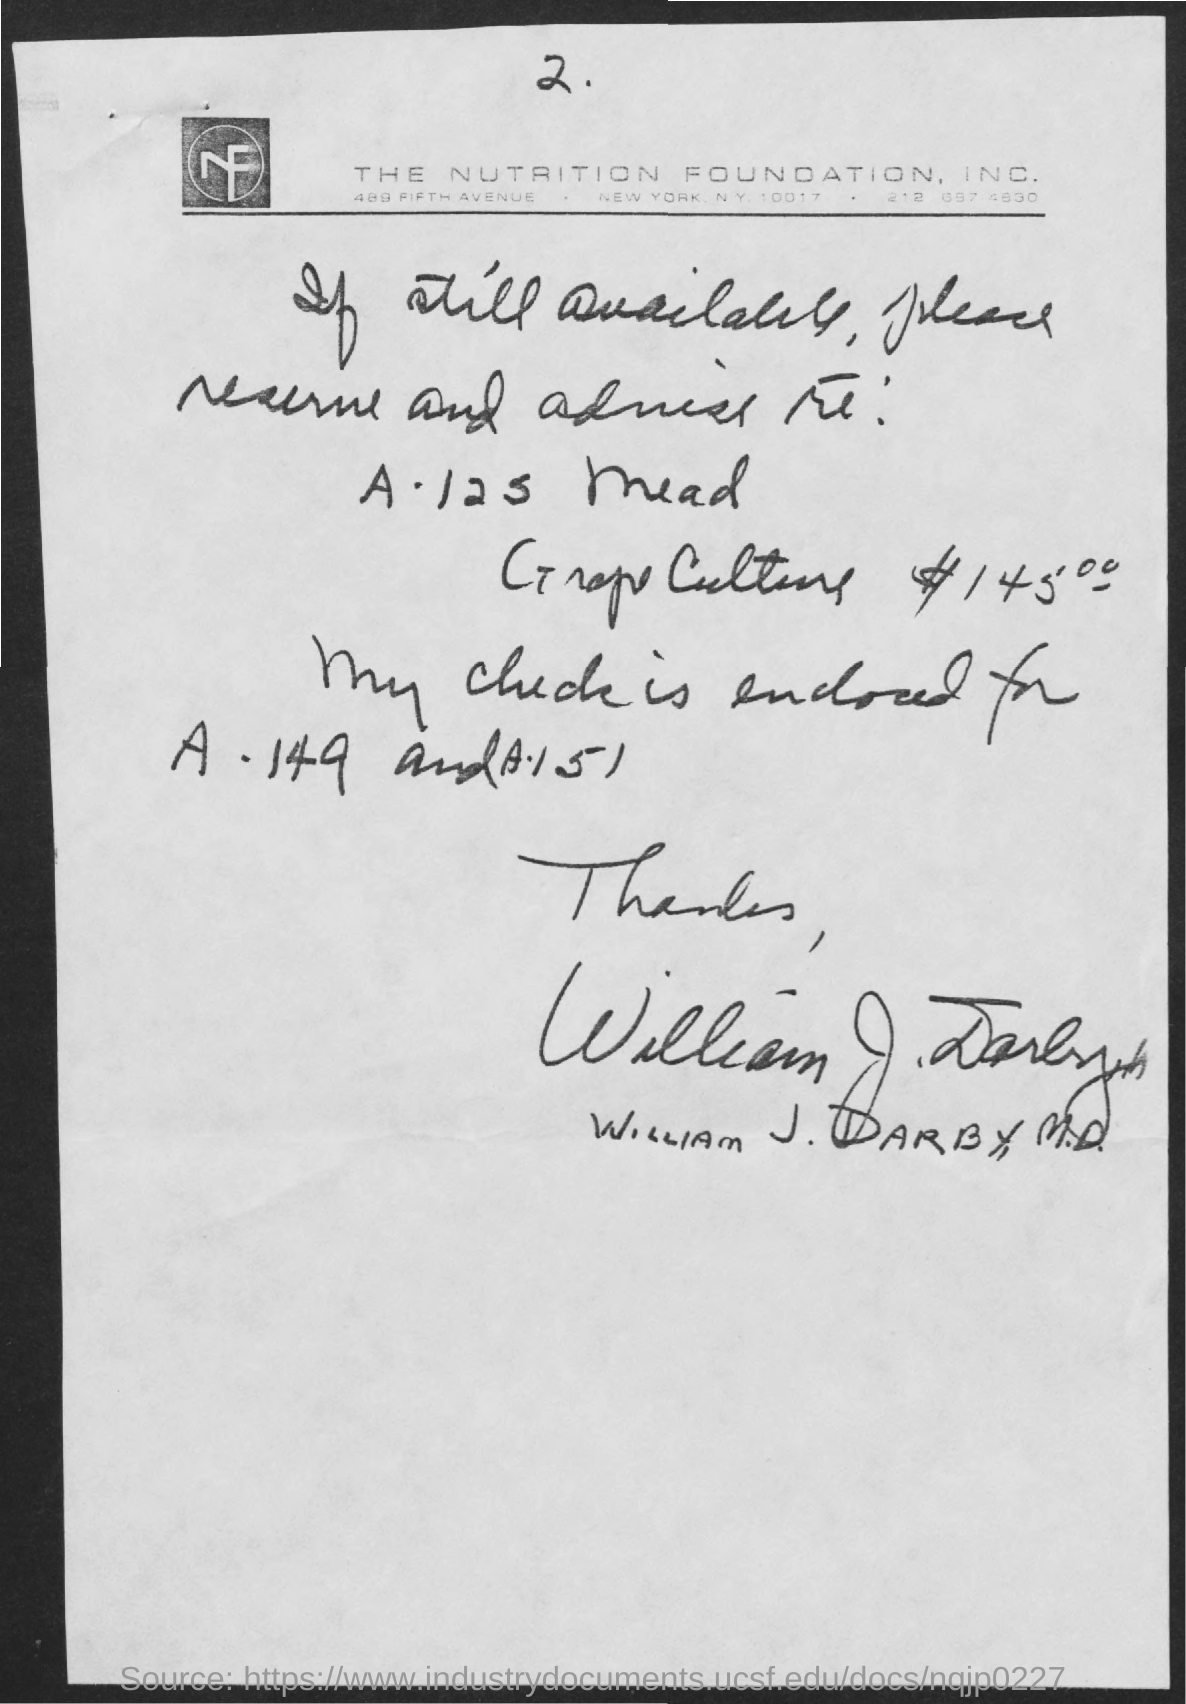List a handful of essential elements in this visual. William J. Darby is the sender of this letter. The nutrition foundation, Inc. is the foundation mentioned in the document. 